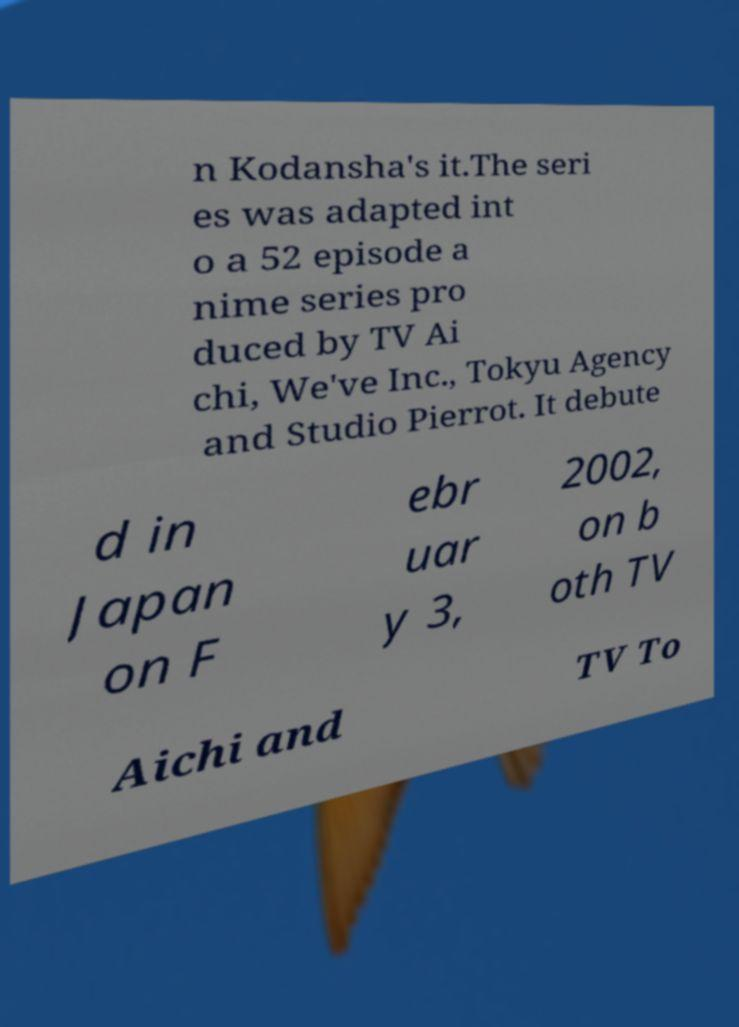Could you extract and type out the text from this image? n Kodansha's it.The seri es was adapted int o a 52 episode a nime series pro duced by TV Ai chi, We've Inc., Tokyu Agency and Studio Pierrot. It debute d in Japan on F ebr uar y 3, 2002, on b oth TV Aichi and TV To 